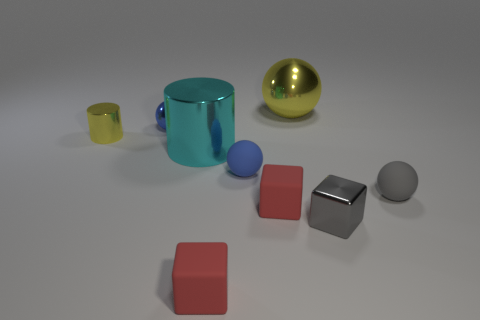The small thing left of the blue ball that is behind the big metallic cylinder is what shape?
Provide a succinct answer. Cylinder. Is there anything else that has the same shape as the gray metal object?
Your answer should be compact. Yes. There is another thing that is the same shape as the tiny yellow metal object; what color is it?
Provide a succinct answer. Cyan. Do the tiny metal ball and the small matte sphere to the left of the big shiny ball have the same color?
Offer a very short reply. Yes. What is the shape of the metallic object that is right of the cyan shiny cylinder and in front of the small yellow thing?
Keep it short and to the point. Cube. Are there fewer large yellow metal objects than small cyan matte spheres?
Make the answer very short. No. Are any rubber things visible?
Offer a very short reply. Yes. How many other objects are the same size as the gray matte object?
Offer a terse response. 6. Are the yellow cylinder and the sphere that is to the left of the cyan metal object made of the same material?
Your answer should be compact. Yes. Are there the same number of small blue balls to the right of the blue matte thing and big metallic objects that are behind the tiny gray sphere?
Provide a short and direct response. No. 